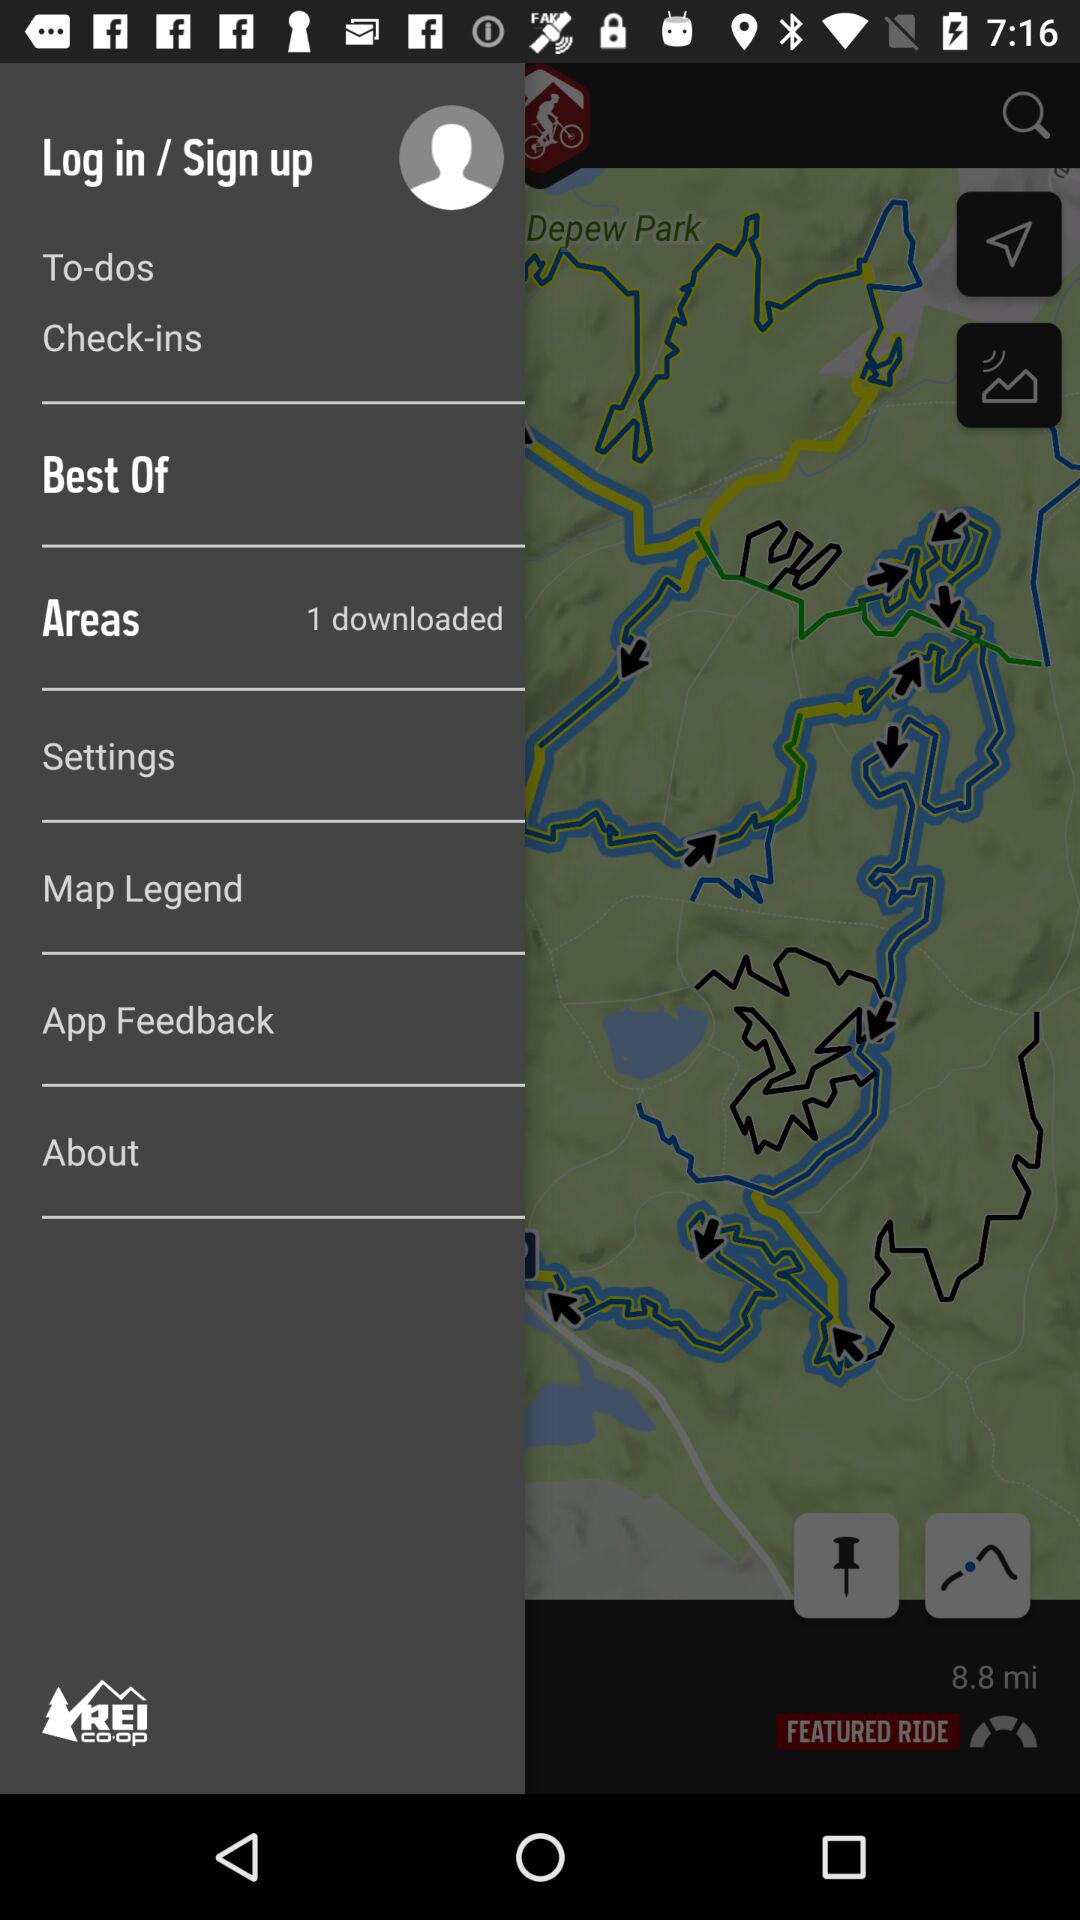How many downloads are there in the item "Areas"? There is 1 download. 